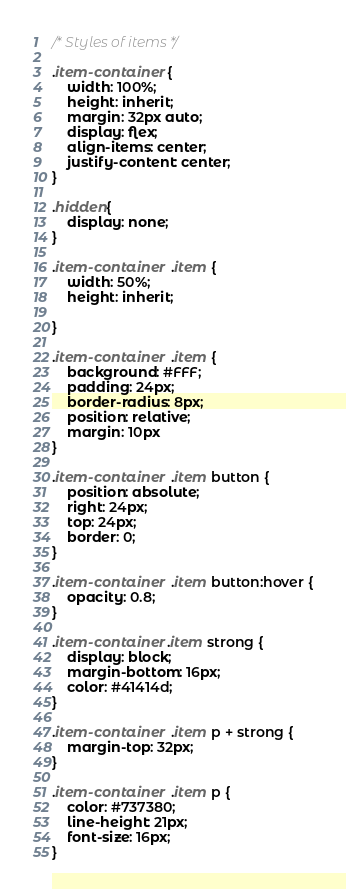Convert code to text. <code><loc_0><loc_0><loc_500><loc_500><_CSS_>/* Styles of items */

.item-container {
    width: 100%;
    height: inherit;
    margin: 32px auto;
    display: flex;
    align-items: center;
    justify-content: center;
}

.hidden{
    display: none;
}

.item-container  .item {
    width: 50%;
    height: inherit;
    
}

.item-container  .item {
    background: #FFF;
    padding: 24px;
    border-radius: 8px;
    position: relative;
    margin: 10px
}

.item-container  .item button {
    position: absolute;
    right: 24px;
    top: 24px;
    border: 0;
}

.item-container  .item button:hover {
    opacity: 0.8;
}

.item-container .item strong {
    display: block;
    margin-bottom: 16px;
    color: #41414d;
}

.item-container  .item p + strong {
    margin-top: 32px;   
}

.item-container  .item p {
    color: #737380;
    line-height: 21px;
    font-size: 16px;
}
</code> 